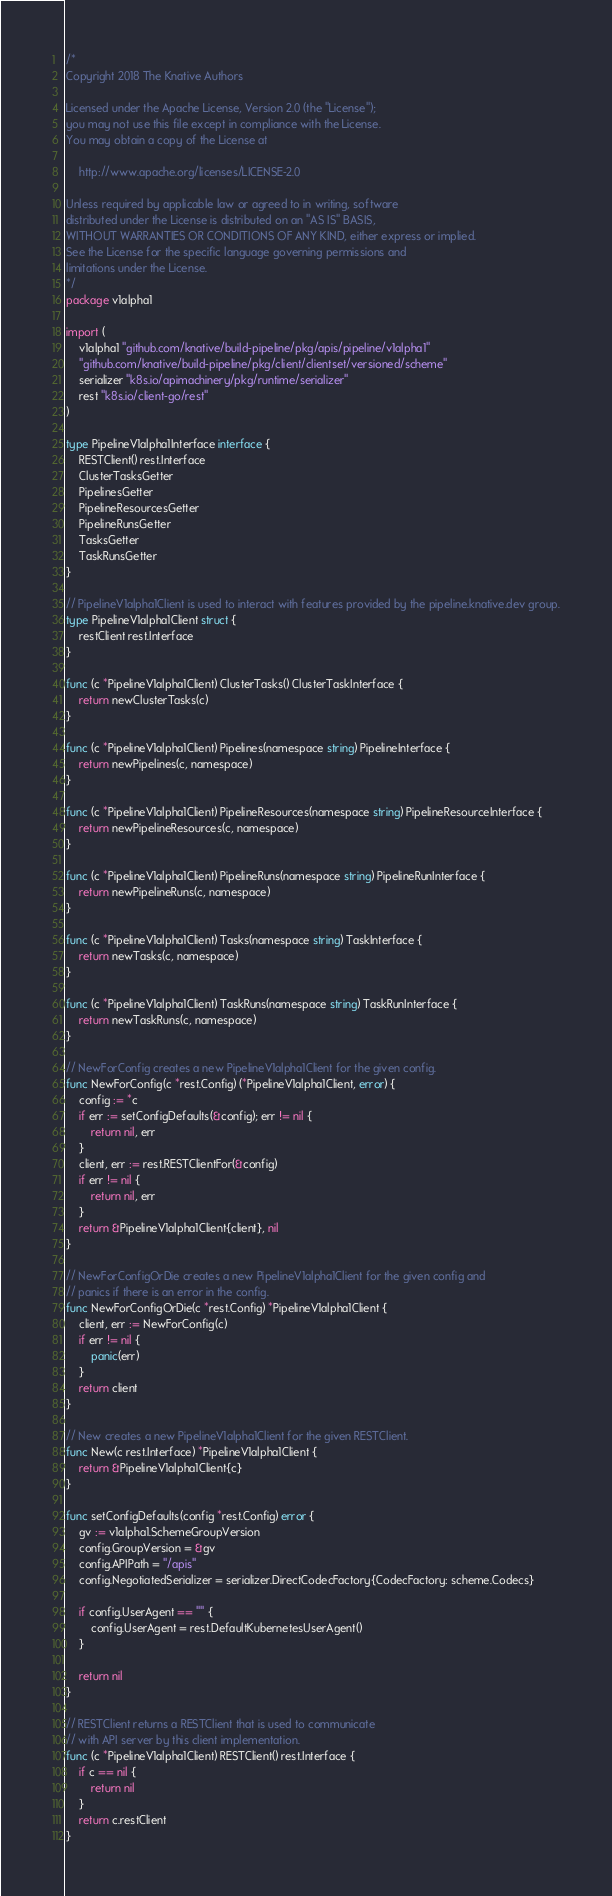<code> <loc_0><loc_0><loc_500><loc_500><_Go_>/*
Copyright 2018 The Knative Authors

Licensed under the Apache License, Version 2.0 (the "License");
you may not use this file except in compliance with the License.
You may obtain a copy of the License at

    http://www.apache.org/licenses/LICENSE-2.0

Unless required by applicable law or agreed to in writing, software
distributed under the License is distributed on an "AS IS" BASIS,
WITHOUT WARRANTIES OR CONDITIONS OF ANY KIND, either express or implied.
See the License for the specific language governing permissions and
limitations under the License.
*/
package v1alpha1

import (
	v1alpha1 "github.com/knative/build-pipeline/pkg/apis/pipeline/v1alpha1"
	"github.com/knative/build-pipeline/pkg/client/clientset/versioned/scheme"
	serializer "k8s.io/apimachinery/pkg/runtime/serializer"
	rest "k8s.io/client-go/rest"
)

type PipelineV1alpha1Interface interface {
	RESTClient() rest.Interface
	ClusterTasksGetter
	PipelinesGetter
	PipelineResourcesGetter
	PipelineRunsGetter
	TasksGetter
	TaskRunsGetter
}

// PipelineV1alpha1Client is used to interact with features provided by the pipeline.knative.dev group.
type PipelineV1alpha1Client struct {
	restClient rest.Interface
}

func (c *PipelineV1alpha1Client) ClusterTasks() ClusterTaskInterface {
	return newClusterTasks(c)
}

func (c *PipelineV1alpha1Client) Pipelines(namespace string) PipelineInterface {
	return newPipelines(c, namespace)
}

func (c *PipelineV1alpha1Client) PipelineResources(namespace string) PipelineResourceInterface {
	return newPipelineResources(c, namespace)
}

func (c *PipelineV1alpha1Client) PipelineRuns(namespace string) PipelineRunInterface {
	return newPipelineRuns(c, namespace)
}

func (c *PipelineV1alpha1Client) Tasks(namespace string) TaskInterface {
	return newTasks(c, namespace)
}

func (c *PipelineV1alpha1Client) TaskRuns(namespace string) TaskRunInterface {
	return newTaskRuns(c, namespace)
}

// NewForConfig creates a new PipelineV1alpha1Client for the given config.
func NewForConfig(c *rest.Config) (*PipelineV1alpha1Client, error) {
	config := *c
	if err := setConfigDefaults(&config); err != nil {
		return nil, err
	}
	client, err := rest.RESTClientFor(&config)
	if err != nil {
		return nil, err
	}
	return &PipelineV1alpha1Client{client}, nil
}

// NewForConfigOrDie creates a new PipelineV1alpha1Client for the given config and
// panics if there is an error in the config.
func NewForConfigOrDie(c *rest.Config) *PipelineV1alpha1Client {
	client, err := NewForConfig(c)
	if err != nil {
		panic(err)
	}
	return client
}

// New creates a new PipelineV1alpha1Client for the given RESTClient.
func New(c rest.Interface) *PipelineV1alpha1Client {
	return &PipelineV1alpha1Client{c}
}

func setConfigDefaults(config *rest.Config) error {
	gv := v1alpha1.SchemeGroupVersion
	config.GroupVersion = &gv
	config.APIPath = "/apis"
	config.NegotiatedSerializer = serializer.DirectCodecFactory{CodecFactory: scheme.Codecs}

	if config.UserAgent == "" {
		config.UserAgent = rest.DefaultKubernetesUserAgent()
	}

	return nil
}

// RESTClient returns a RESTClient that is used to communicate
// with API server by this client implementation.
func (c *PipelineV1alpha1Client) RESTClient() rest.Interface {
	if c == nil {
		return nil
	}
	return c.restClient
}
</code> 